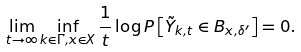Convert formula to latex. <formula><loc_0><loc_0><loc_500><loc_500>\lim _ { t \rightarrow \infty } \inf _ { k \in \Gamma , x \in X } \frac { 1 } { t } \log P \left [ \tilde { Y } _ { k , t } \in B _ { x , \delta ^ { \prime } } \right ] = 0 .</formula> 